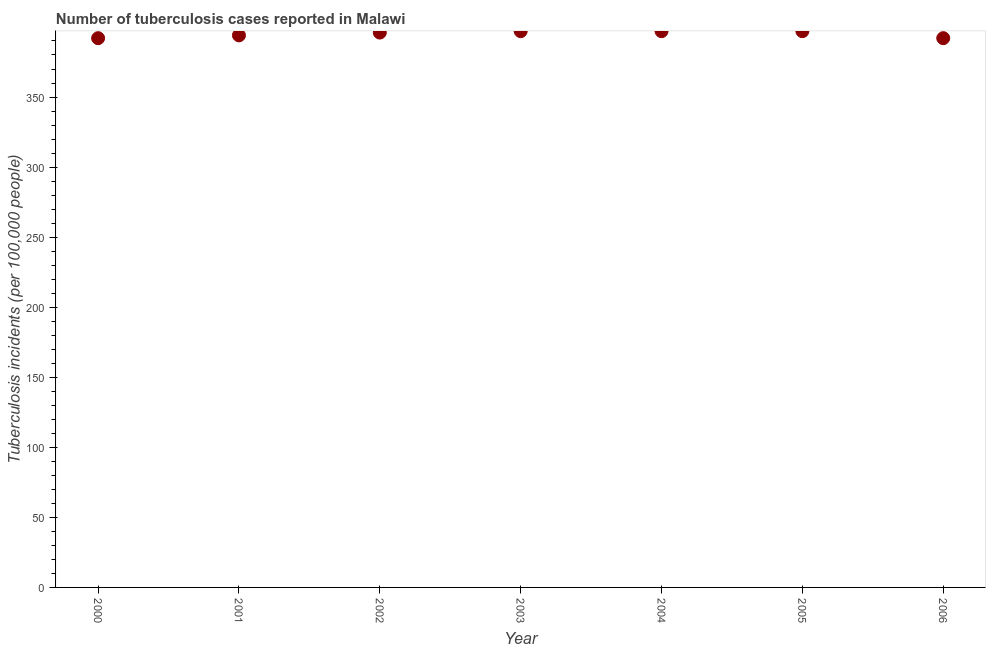What is the number of tuberculosis incidents in 2001?
Your answer should be compact. 394. Across all years, what is the maximum number of tuberculosis incidents?
Your response must be concise. 397. Across all years, what is the minimum number of tuberculosis incidents?
Provide a succinct answer. 392. In which year was the number of tuberculosis incidents maximum?
Provide a succinct answer. 2003. What is the sum of the number of tuberculosis incidents?
Provide a succinct answer. 2765. What is the difference between the number of tuberculosis incidents in 2001 and 2002?
Give a very brief answer. -2. What is the average number of tuberculosis incidents per year?
Keep it short and to the point. 395. What is the median number of tuberculosis incidents?
Keep it short and to the point. 396. In how many years, is the number of tuberculosis incidents greater than 190 ?
Provide a short and direct response. 7. What is the ratio of the number of tuberculosis incidents in 2001 to that in 2004?
Keep it short and to the point. 0.99. Is the number of tuberculosis incidents in 2000 less than that in 2002?
Provide a short and direct response. Yes. What is the difference between the highest and the second highest number of tuberculosis incidents?
Ensure brevity in your answer.  0. Is the sum of the number of tuberculosis incidents in 2000 and 2004 greater than the maximum number of tuberculosis incidents across all years?
Your answer should be compact. Yes. What is the difference between the highest and the lowest number of tuberculosis incidents?
Offer a very short reply. 5. In how many years, is the number of tuberculosis incidents greater than the average number of tuberculosis incidents taken over all years?
Your answer should be compact. 4. How many dotlines are there?
Keep it short and to the point. 1. What is the difference between two consecutive major ticks on the Y-axis?
Provide a succinct answer. 50. What is the title of the graph?
Ensure brevity in your answer.  Number of tuberculosis cases reported in Malawi. What is the label or title of the X-axis?
Provide a succinct answer. Year. What is the label or title of the Y-axis?
Offer a very short reply. Tuberculosis incidents (per 100,0 people). What is the Tuberculosis incidents (per 100,000 people) in 2000?
Provide a succinct answer. 392. What is the Tuberculosis incidents (per 100,000 people) in 2001?
Provide a short and direct response. 394. What is the Tuberculosis incidents (per 100,000 people) in 2002?
Your response must be concise. 396. What is the Tuberculosis incidents (per 100,000 people) in 2003?
Ensure brevity in your answer.  397. What is the Tuberculosis incidents (per 100,000 people) in 2004?
Give a very brief answer. 397. What is the Tuberculosis incidents (per 100,000 people) in 2005?
Your response must be concise. 397. What is the Tuberculosis incidents (per 100,000 people) in 2006?
Provide a short and direct response. 392. What is the difference between the Tuberculosis incidents (per 100,000 people) in 2000 and 2004?
Make the answer very short. -5. What is the difference between the Tuberculosis incidents (per 100,000 people) in 2000 and 2006?
Offer a very short reply. 0. What is the difference between the Tuberculosis incidents (per 100,000 people) in 2001 and 2003?
Provide a succinct answer. -3. What is the difference between the Tuberculosis incidents (per 100,000 people) in 2001 and 2006?
Your answer should be compact. 2. What is the difference between the Tuberculosis incidents (per 100,000 people) in 2002 and 2003?
Offer a terse response. -1. What is the difference between the Tuberculosis incidents (per 100,000 people) in 2002 and 2004?
Offer a very short reply. -1. What is the difference between the Tuberculosis incidents (per 100,000 people) in 2002 and 2005?
Ensure brevity in your answer.  -1. What is the difference between the Tuberculosis incidents (per 100,000 people) in 2002 and 2006?
Offer a terse response. 4. What is the difference between the Tuberculosis incidents (per 100,000 people) in 2003 and 2005?
Provide a short and direct response. 0. What is the difference between the Tuberculosis incidents (per 100,000 people) in 2004 and 2005?
Your answer should be compact. 0. What is the difference between the Tuberculosis incidents (per 100,000 people) in 2004 and 2006?
Provide a succinct answer. 5. What is the difference between the Tuberculosis incidents (per 100,000 people) in 2005 and 2006?
Offer a terse response. 5. What is the ratio of the Tuberculosis incidents (per 100,000 people) in 2000 to that in 2001?
Keep it short and to the point. 0.99. What is the ratio of the Tuberculosis incidents (per 100,000 people) in 2000 to that in 2003?
Your answer should be very brief. 0.99. What is the ratio of the Tuberculosis incidents (per 100,000 people) in 2000 to that in 2006?
Provide a short and direct response. 1. What is the ratio of the Tuberculosis incidents (per 100,000 people) in 2001 to that in 2002?
Your answer should be compact. 0.99. What is the ratio of the Tuberculosis incidents (per 100,000 people) in 2001 to that in 2004?
Give a very brief answer. 0.99. What is the ratio of the Tuberculosis incidents (per 100,000 people) in 2001 to that in 2005?
Ensure brevity in your answer.  0.99. What is the ratio of the Tuberculosis incidents (per 100,000 people) in 2002 to that in 2003?
Give a very brief answer. 1. What is the ratio of the Tuberculosis incidents (per 100,000 people) in 2002 to that in 2006?
Your response must be concise. 1.01. What is the ratio of the Tuberculosis incidents (per 100,000 people) in 2003 to that in 2004?
Give a very brief answer. 1. What is the ratio of the Tuberculosis incidents (per 100,000 people) in 2003 to that in 2006?
Ensure brevity in your answer.  1.01. What is the ratio of the Tuberculosis incidents (per 100,000 people) in 2004 to that in 2006?
Ensure brevity in your answer.  1.01. What is the ratio of the Tuberculosis incidents (per 100,000 people) in 2005 to that in 2006?
Provide a succinct answer. 1.01. 